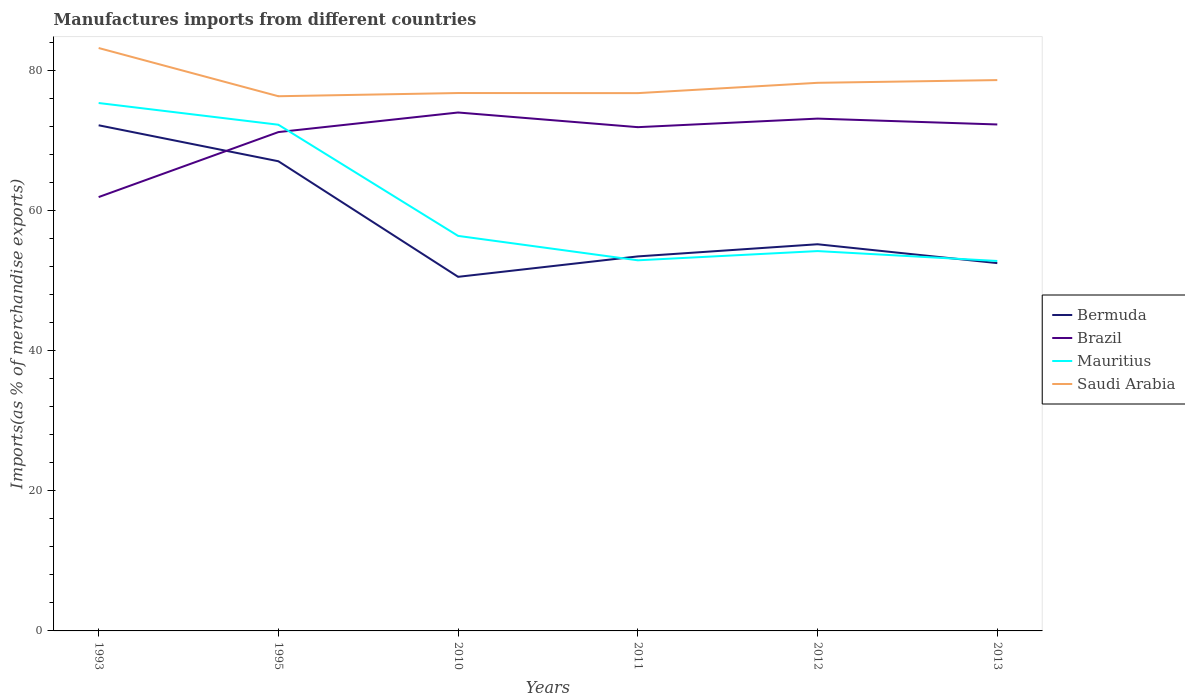How many different coloured lines are there?
Give a very brief answer. 4. Across all years, what is the maximum percentage of imports to different countries in Bermuda?
Make the answer very short. 50.55. In which year was the percentage of imports to different countries in Brazil maximum?
Your answer should be compact. 1993. What is the total percentage of imports to different countries in Brazil in the graph?
Keep it short and to the point. 2.09. What is the difference between the highest and the second highest percentage of imports to different countries in Brazil?
Your response must be concise. 12.07. How many lines are there?
Your answer should be compact. 4. How many years are there in the graph?
Provide a short and direct response. 6. What is the difference between two consecutive major ticks on the Y-axis?
Your response must be concise. 20. Are the values on the major ticks of Y-axis written in scientific E-notation?
Ensure brevity in your answer.  No. Does the graph contain grids?
Provide a short and direct response. No. Where does the legend appear in the graph?
Provide a succinct answer. Center right. What is the title of the graph?
Provide a short and direct response. Manufactures imports from different countries. What is the label or title of the Y-axis?
Give a very brief answer. Imports(as % of merchandise exports). What is the Imports(as % of merchandise exports) of Bermuda in 1993?
Your answer should be compact. 72.18. What is the Imports(as % of merchandise exports) in Brazil in 1993?
Offer a very short reply. 61.93. What is the Imports(as % of merchandise exports) in Mauritius in 1993?
Provide a succinct answer. 75.36. What is the Imports(as % of merchandise exports) in Saudi Arabia in 1993?
Provide a short and direct response. 83.21. What is the Imports(as % of merchandise exports) in Bermuda in 1995?
Give a very brief answer. 67.04. What is the Imports(as % of merchandise exports) in Brazil in 1995?
Offer a very short reply. 71.21. What is the Imports(as % of merchandise exports) of Mauritius in 1995?
Provide a short and direct response. 72.26. What is the Imports(as % of merchandise exports) of Saudi Arabia in 1995?
Ensure brevity in your answer.  76.33. What is the Imports(as % of merchandise exports) in Bermuda in 2010?
Keep it short and to the point. 50.55. What is the Imports(as % of merchandise exports) of Brazil in 2010?
Keep it short and to the point. 74. What is the Imports(as % of merchandise exports) in Mauritius in 2010?
Give a very brief answer. 56.39. What is the Imports(as % of merchandise exports) in Saudi Arabia in 2010?
Your answer should be very brief. 76.78. What is the Imports(as % of merchandise exports) of Bermuda in 2011?
Your answer should be compact. 53.46. What is the Imports(as % of merchandise exports) of Brazil in 2011?
Provide a short and direct response. 71.91. What is the Imports(as % of merchandise exports) of Mauritius in 2011?
Your response must be concise. 52.91. What is the Imports(as % of merchandise exports) in Saudi Arabia in 2011?
Your answer should be very brief. 76.77. What is the Imports(as % of merchandise exports) in Bermuda in 2012?
Offer a terse response. 55.2. What is the Imports(as % of merchandise exports) of Brazil in 2012?
Keep it short and to the point. 73.13. What is the Imports(as % of merchandise exports) of Mauritius in 2012?
Your answer should be very brief. 54.22. What is the Imports(as % of merchandise exports) of Saudi Arabia in 2012?
Offer a terse response. 78.24. What is the Imports(as % of merchandise exports) in Bermuda in 2013?
Offer a very short reply. 52.5. What is the Imports(as % of merchandise exports) in Brazil in 2013?
Offer a very short reply. 72.29. What is the Imports(as % of merchandise exports) of Mauritius in 2013?
Give a very brief answer. 52.81. What is the Imports(as % of merchandise exports) in Saudi Arabia in 2013?
Provide a short and direct response. 78.63. Across all years, what is the maximum Imports(as % of merchandise exports) in Bermuda?
Give a very brief answer. 72.18. Across all years, what is the maximum Imports(as % of merchandise exports) in Brazil?
Make the answer very short. 74. Across all years, what is the maximum Imports(as % of merchandise exports) in Mauritius?
Give a very brief answer. 75.36. Across all years, what is the maximum Imports(as % of merchandise exports) in Saudi Arabia?
Provide a succinct answer. 83.21. Across all years, what is the minimum Imports(as % of merchandise exports) in Bermuda?
Provide a short and direct response. 50.55. Across all years, what is the minimum Imports(as % of merchandise exports) of Brazil?
Your response must be concise. 61.93. Across all years, what is the minimum Imports(as % of merchandise exports) in Mauritius?
Make the answer very short. 52.81. Across all years, what is the minimum Imports(as % of merchandise exports) of Saudi Arabia?
Keep it short and to the point. 76.33. What is the total Imports(as % of merchandise exports) of Bermuda in the graph?
Your answer should be very brief. 350.93. What is the total Imports(as % of merchandise exports) of Brazil in the graph?
Keep it short and to the point. 424.48. What is the total Imports(as % of merchandise exports) of Mauritius in the graph?
Give a very brief answer. 363.94. What is the total Imports(as % of merchandise exports) in Saudi Arabia in the graph?
Your answer should be compact. 469.96. What is the difference between the Imports(as % of merchandise exports) of Bermuda in 1993 and that in 1995?
Offer a very short reply. 5.13. What is the difference between the Imports(as % of merchandise exports) in Brazil in 1993 and that in 1995?
Your answer should be compact. -9.28. What is the difference between the Imports(as % of merchandise exports) of Mauritius in 1993 and that in 1995?
Your response must be concise. 3.1. What is the difference between the Imports(as % of merchandise exports) of Saudi Arabia in 1993 and that in 1995?
Offer a very short reply. 6.88. What is the difference between the Imports(as % of merchandise exports) of Bermuda in 1993 and that in 2010?
Offer a terse response. 21.63. What is the difference between the Imports(as % of merchandise exports) in Brazil in 1993 and that in 2010?
Give a very brief answer. -12.07. What is the difference between the Imports(as % of merchandise exports) in Mauritius in 1993 and that in 2010?
Offer a very short reply. 18.97. What is the difference between the Imports(as % of merchandise exports) in Saudi Arabia in 1993 and that in 2010?
Provide a short and direct response. 6.43. What is the difference between the Imports(as % of merchandise exports) in Bermuda in 1993 and that in 2011?
Make the answer very short. 18.72. What is the difference between the Imports(as % of merchandise exports) of Brazil in 1993 and that in 2011?
Provide a succinct answer. -9.98. What is the difference between the Imports(as % of merchandise exports) in Mauritius in 1993 and that in 2011?
Your response must be concise. 22.45. What is the difference between the Imports(as % of merchandise exports) of Saudi Arabia in 1993 and that in 2011?
Make the answer very short. 6.44. What is the difference between the Imports(as % of merchandise exports) of Bermuda in 1993 and that in 2012?
Give a very brief answer. 16.98. What is the difference between the Imports(as % of merchandise exports) of Brazil in 1993 and that in 2012?
Provide a succinct answer. -11.2. What is the difference between the Imports(as % of merchandise exports) of Mauritius in 1993 and that in 2012?
Provide a short and direct response. 21.14. What is the difference between the Imports(as % of merchandise exports) in Saudi Arabia in 1993 and that in 2012?
Provide a succinct answer. 4.97. What is the difference between the Imports(as % of merchandise exports) in Bermuda in 1993 and that in 2013?
Offer a terse response. 19.68. What is the difference between the Imports(as % of merchandise exports) in Brazil in 1993 and that in 2013?
Keep it short and to the point. -10.36. What is the difference between the Imports(as % of merchandise exports) in Mauritius in 1993 and that in 2013?
Provide a short and direct response. 22.55. What is the difference between the Imports(as % of merchandise exports) of Saudi Arabia in 1993 and that in 2013?
Your answer should be compact. 4.58. What is the difference between the Imports(as % of merchandise exports) in Bermuda in 1995 and that in 2010?
Provide a succinct answer. 16.5. What is the difference between the Imports(as % of merchandise exports) in Brazil in 1995 and that in 2010?
Provide a short and direct response. -2.8. What is the difference between the Imports(as % of merchandise exports) in Mauritius in 1995 and that in 2010?
Your answer should be very brief. 15.87. What is the difference between the Imports(as % of merchandise exports) of Saudi Arabia in 1995 and that in 2010?
Make the answer very short. -0.46. What is the difference between the Imports(as % of merchandise exports) of Bermuda in 1995 and that in 2011?
Your answer should be compact. 13.58. What is the difference between the Imports(as % of merchandise exports) in Brazil in 1995 and that in 2011?
Your answer should be very brief. -0.7. What is the difference between the Imports(as % of merchandise exports) of Mauritius in 1995 and that in 2011?
Your answer should be compact. 19.35. What is the difference between the Imports(as % of merchandise exports) of Saudi Arabia in 1995 and that in 2011?
Your response must be concise. -0.44. What is the difference between the Imports(as % of merchandise exports) of Bermuda in 1995 and that in 2012?
Ensure brevity in your answer.  11.85. What is the difference between the Imports(as % of merchandise exports) in Brazil in 1995 and that in 2012?
Offer a terse response. -1.92. What is the difference between the Imports(as % of merchandise exports) in Mauritius in 1995 and that in 2012?
Your answer should be very brief. 18.04. What is the difference between the Imports(as % of merchandise exports) in Saudi Arabia in 1995 and that in 2012?
Your answer should be very brief. -1.92. What is the difference between the Imports(as % of merchandise exports) of Bermuda in 1995 and that in 2013?
Provide a short and direct response. 14.54. What is the difference between the Imports(as % of merchandise exports) in Brazil in 1995 and that in 2013?
Your response must be concise. -1.09. What is the difference between the Imports(as % of merchandise exports) of Mauritius in 1995 and that in 2013?
Keep it short and to the point. 19.45. What is the difference between the Imports(as % of merchandise exports) of Saudi Arabia in 1995 and that in 2013?
Your answer should be very brief. -2.31. What is the difference between the Imports(as % of merchandise exports) of Bermuda in 2010 and that in 2011?
Keep it short and to the point. -2.91. What is the difference between the Imports(as % of merchandise exports) in Brazil in 2010 and that in 2011?
Provide a succinct answer. 2.09. What is the difference between the Imports(as % of merchandise exports) in Mauritius in 2010 and that in 2011?
Provide a succinct answer. 3.48. What is the difference between the Imports(as % of merchandise exports) in Saudi Arabia in 2010 and that in 2011?
Your answer should be compact. 0.01. What is the difference between the Imports(as % of merchandise exports) in Bermuda in 2010 and that in 2012?
Offer a terse response. -4.65. What is the difference between the Imports(as % of merchandise exports) in Brazil in 2010 and that in 2012?
Offer a very short reply. 0.87. What is the difference between the Imports(as % of merchandise exports) of Mauritius in 2010 and that in 2012?
Your answer should be compact. 2.17. What is the difference between the Imports(as % of merchandise exports) of Saudi Arabia in 2010 and that in 2012?
Your answer should be compact. -1.46. What is the difference between the Imports(as % of merchandise exports) of Bermuda in 2010 and that in 2013?
Offer a very short reply. -1.96. What is the difference between the Imports(as % of merchandise exports) of Brazil in 2010 and that in 2013?
Your response must be concise. 1.71. What is the difference between the Imports(as % of merchandise exports) in Mauritius in 2010 and that in 2013?
Ensure brevity in your answer.  3.58. What is the difference between the Imports(as % of merchandise exports) of Saudi Arabia in 2010 and that in 2013?
Ensure brevity in your answer.  -1.85. What is the difference between the Imports(as % of merchandise exports) in Bermuda in 2011 and that in 2012?
Provide a succinct answer. -1.74. What is the difference between the Imports(as % of merchandise exports) in Brazil in 2011 and that in 2012?
Provide a succinct answer. -1.22. What is the difference between the Imports(as % of merchandise exports) of Mauritius in 2011 and that in 2012?
Your response must be concise. -1.32. What is the difference between the Imports(as % of merchandise exports) of Saudi Arabia in 2011 and that in 2012?
Ensure brevity in your answer.  -1.47. What is the difference between the Imports(as % of merchandise exports) of Brazil in 2011 and that in 2013?
Provide a short and direct response. -0.38. What is the difference between the Imports(as % of merchandise exports) in Mauritius in 2011 and that in 2013?
Your answer should be very brief. 0.1. What is the difference between the Imports(as % of merchandise exports) in Saudi Arabia in 2011 and that in 2013?
Give a very brief answer. -1.86. What is the difference between the Imports(as % of merchandise exports) in Bermuda in 2012 and that in 2013?
Offer a very short reply. 2.69. What is the difference between the Imports(as % of merchandise exports) in Brazil in 2012 and that in 2013?
Your response must be concise. 0.84. What is the difference between the Imports(as % of merchandise exports) of Mauritius in 2012 and that in 2013?
Provide a short and direct response. 1.41. What is the difference between the Imports(as % of merchandise exports) of Saudi Arabia in 2012 and that in 2013?
Give a very brief answer. -0.39. What is the difference between the Imports(as % of merchandise exports) in Bermuda in 1993 and the Imports(as % of merchandise exports) in Brazil in 1995?
Ensure brevity in your answer.  0.97. What is the difference between the Imports(as % of merchandise exports) in Bermuda in 1993 and the Imports(as % of merchandise exports) in Mauritius in 1995?
Your response must be concise. -0.08. What is the difference between the Imports(as % of merchandise exports) of Bermuda in 1993 and the Imports(as % of merchandise exports) of Saudi Arabia in 1995?
Provide a short and direct response. -4.15. What is the difference between the Imports(as % of merchandise exports) of Brazil in 1993 and the Imports(as % of merchandise exports) of Mauritius in 1995?
Your response must be concise. -10.33. What is the difference between the Imports(as % of merchandise exports) in Brazil in 1993 and the Imports(as % of merchandise exports) in Saudi Arabia in 1995?
Make the answer very short. -14.39. What is the difference between the Imports(as % of merchandise exports) in Mauritius in 1993 and the Imports(as % of merchandise exports) in Saudi Arabia in 1995?
Offer a very short reply. -0.97. What is the difference between the Imports(as % of merchandise exports) of Bermuda in 1993 and the Imports(as % of merchandise exports) of Brazil in 2010?
Your response must be concise. -1.82. What is the difference between the Imports(as % of merchandise exports) in Bermuda in 1993 and the Imports(as % of merchandise exports) in Mauritius in 2010?
Give a very brief answer. 15.79. What is the difference between the Imports(as % of merchandise exports) in Bermuda in 1993 and the Imports(as % of merchandise exports) in Saudi Arabia in 2010?
Your answer should be compact. -4.6. What is the difference between the Imports(as % of merchandise exports) of Brazil in 1993 and the Imports(as % of merchandise exports) of Mauritius in 2010?
Provide a short and direct response. 5.54. What is the difference between the Imports(as % of merchandise exports) of Brazil in 1993 and the Imports(as % of merchandise exports) of Saudi Arabia in 2010?
Your response must be concise. -14.85. What is the difference between the Imports(as % of merchandise exports) of Mauritius in 1993 and the Imports(as % of merchandise exports) of Saudi Arabia in 2010?
Offer a terse response. -1.42. What is the difference between the Imports(as % of merchandise exports) of Bermuda in 1993 and the Imports(as % of merchandise exports) of Brazil in 2011?
Your answer should be compact. 0.27. What is the difference between the Imports(as % of merchandise exports) in Bermuda in 1993 and the Imports(as % of merchandise exports) in Mauritius in 2011?
Make the answer very short. 19.27. What is the difference between the Imports(as % of merchandise exports) in Bermuda in 1993 and the Imports(as % of merchandise exports) in Saudi Arabia in 2011?
Provide a short and direct response. -4.59. What is the difference between the Imports(as % of merchandise exports) in Brazil in 1993 and the Imports(as % of merchandise exports) in Mauritius in 2011?
Your response must be concise. 9.03. What is the difference between the Imports(as % of merchandise exports) of Brazil in 1993 and the Imports(as % of merchandise exports) of Saudi Arabia in 2011?
Provide a succinct answer. -14.84. What is the difference between the Imports(as % of merchandise exports) of Mauritius in 1993 and the Imports(as % of merchandise exports) of Saudi Arabia in 2011?
Provide a succinct answer. -1.41. What is the difference between the Imports(as % of merchandise exports) of Bermuda in 1993 and the Imports(as % of merchandise exports) of Brazil in 2012?
Offer a very short reply. -0.95. What is the difference between the Imports(as % of merchandise exports) in Bermuda in 1993 and the Imports(as % of merchandise exports) in Mauritius in 2012?
Your response must be concise. 17.96. What is the difference between the Imports(as % of merchandise exports) in Bermuda in 1993 and the Imports(as % of merchandise exports) in Saudi Arabia in 2012?
Provide a succinct answer. -6.06. What is the difference between the Imports(as % of merchandise exports) in Brazil in 1993 and the Imports(as % of merchandise exports) in Mauritius in 2012?
Give a very brief answer. 7.71. What is the difference between the Imports(as % of merchandise exports) of Brazil in 1993 and the Imports(as % of merchandise exports) of Saudi Arabia in 2012?
Give a very brief answer. -16.31. What is the difference between the Imports(as % of merchandise exports) in Mauritius in 1993 and the Imports(as % of merchandise exports) in Saudi Arabia in 2012?
Give a very brief answer. -2.88. What is the difference between the Imports(as % of merchandise exports) in Bermuda in 1993 and the Imports(as % of merchandise exports) in Brazil in 2013?
Provide a succinct answer. -0.12. What is the difference between the Imports(as % of merchandise exports) of Bermuda in 1993 and the Imports(as % of merchandise exports) of Mauritius in 2013?
Make the answer very short. 19.37. What is the difference between the Imports(as % of merchandise exports) of Bermuda in 1993 and the Imports(as % of merchandise exports) of Saudi Arabia in 2013?
Provide a short and direct response. -6.45. What is the difference between the Imports(as % of merchandise exports) in Brazil in 1993 and the Imports(as % of merchandise exports) in Mauritius in 2013?
Your answer should be very brief. 9.12. What is the difference between the Imports(as % of merchandise exports) in Brazil in 1993 and the Imports(as % of merchandise exports) in Saudi Arabia in 2013?
Provide a succinct answer. -16.7. What is the difference between the Imports(as % of merchandise exports) of Mauritius in 1993 and the Imports(as % of merchandise exports) of Saudi Arabia in 2013?
Your answer should be compact. -3.27. What is the difference between the Imports(as % of merchandise exports) in Bermuda in 1995 and the Imports(as % of merchandise exports) in Brazil in 2010?
Offer a very short reply. -6.96. What is the difference between the Imports(as % of merchandise exports) of Bermuda in 1995 and the Imports(as % of merchandise exports) of Mauritius in 2010?
Your response must be concise. 10.65. What is the difference between the Imports(as % of merchandise exports) of Bermuda in 1995 and the Imports(as % of merchandise exports) of Saudi Arabia in 2010?
Your answer should be very brief. -9.74. What is the difference between the Imports(as % of merchandise exports) in Brazil in 1995 and the Imports(as % of merchandise exports) in Mauritius in 2010?
Your answer should be compact. 14.82. What is the difference between the Imports(as % of merchandise exports) of Brazil in 1995 and the Imports(as % of merchandise exports) of Saudi Arabia in 2010?
Your answer should be very brief. -5.58. What is the difference between the Imports(as % of merchandise exports) of Mauritius in 1995 and the Imports(as % of merchandise exports) of Saudi Arabia in 2010?
Offer a very short reply. -4.52. What is the difference between the Imports(as % of merchandise exports) of Bermuda in 1995 and the Imports(as % of merchandise exports) of Brazil in 2011?
Make the answer very short. -4.87. What is the difference between the Imports(as % of merchandise exports) of Bermuda in 1995 and the Imports(as % of merchandise exports) of Mauritius in 2011?
Make the answer very short. 14.14. What is the difference between the Imports(as % of merchandise exports) of Bermuda in 1995 and the Imports(as % of merchandise exports) of Saudi Arabia in 2011?
Provide a succinct answer. -9.72. What is the difference between the Imports(as % of merchandise exports) of Brazil in 1995 and the Imports(as % of merchandise exports) of Mauritius in 2011?
Keep it short and to the point. 18.3. What is the difference between the Imports(as % of merchandise exports) of Brazil in 1995 and the Imports(as % of merchandise exports) of Saudi Arabia in 2011?
Ensure brevity in your answer.  -5.56. What is the difference between the Imports(as % of merchandise exports) in Mauritius in 1995 and the Imports(as % of merchandise exports) in Saudi Arabia in 2011?
Keep it short and to the point. -4.51. What is the difference between the Imports(as % of merchandise exports) in Bermuda in 1995 and the Imports(as % of merchandise exports) in Brazil in 2012?
Your response must be concise. -6.09. What is the difference between the Imports(as % of merchandise exports) in Bermuda in 1995 and the Imports(as % of merchandise exports) in Mauritius in 2012?
Your response must be concise. 12.82. What is the difference between the Imports(as % of merchandise exports) of Bermuda in 1995 and the Imports(as % of merchandise exports) of Saudi Arabia in 2012?
Keep it short and to the point. -11.2. What is the difference between the Imports(as % of merchandise exports) in Brazil in 1995 and the Imports(as % of merchandise exports) in Mauritius in 2012?
Offer a terse response. 16.99. What is the difference between the Imports(as % of merchandise exports) in Brazil in 1995 and the Imports(as % of merchandise exports) in Saudi Arabia in 2012?
Your response must be concise. -7.04. What is the difference between the Imports(as % of merchandise exports) of Mauritius in 1995 and the Imports(as % of merchandise exports) of Saudi Arabia in 2012?
Your response must be concise. -5.98. What is the difference between the Imports(as % of merchandise exports) of Bermuda in 1995 and the Imports(as % of merchandise exports) of Brazil in 2013?
Offer a very short reply. -5.25. What is the difference between the Imports(as % of merchandise exports) of Bermuda in 1995 and the Imports(as % of merchandise exports) of Mauritius in 2013?
Offer a terse response. 14.24. What is the difference between the Imports(as % of merchandise exports) of Bermuda in 1995 and the Imports(as % of merchandise exports) of Saudi Arabia in 2013?
Keep it short and to the point. -11.59. What is the difference between the Imports(as % of merchandise exports) in Brazil in 1995 and the Imports(as % of merchandise exports) in Mauritius in 2013?
Your response must be concise. 18.4. What is the difference between the Imports(as % of merchandise exports) in Brazil in 1995 and the Imports(as % of merchandise exports) in Saudi Arabia in 2013?
Your answer should be very brief. -7.42. What is the difference between the Imports(as % of merchandise exports) in Mauritius in 1995 and the Imports(as % of merchandise exports) in Saudi Arabia in 2013?
Provide a short and direct response. -6.37. What is the difference between the Imports(as % of merchandise exports) of Bermuda in 2010 and the Imports(as % of merchandise exports) of Brazil in 2011?
Offer a terse response. -21.36. What is the difference between the Imports(as % of merchandise exports) in Bermuda in 2010 and the Imports(as % of merchandise exports) in Mauritius in 2011?
Your answer should be compact. -2.36. What is the difference between the Imports(as % of merchandise exports) in Bermuda in 2010 and the Imports(as % of merchandise exports) in Saudi Arabia in 2011?
Keep it short and to the point. -26.22. What is the difference between the Imports(as % of merchandise exports) of Brazil in 2010 and the Imports(as % of merchandise exports) of Mauritius in 2011?
Give a very brief answer. 21.1. What is the difference between the Imports(as % of merchandise exports) in Brazil in 2010 and the Imports(as % of merchandise exports) in Saudi Arabia in 2011?
Offer a very short reply. -2.77. What is the difference between the Imports(as % of merchandise exports) in Mauritius in 2010 and the Imports(as % of merchandise exports) in Saudi Arabia in 2011?
Give a very brief answer. -20.38. What is the difference between the Imports(as % of merchandise exports) of Bermuda in 2010 and the Imports(as % of merchandise exports) of Brazil in 2012?
Give a very brief answer. -22.58. What is the difference between the Imports(as % of merchandise exports) of Bermuda in 2010 and the Imports(as % of merchandise exports) of Mauritius in 2012?
Provide a succinct answer. -3.67. What is the difference between the Imports(as % of merchandise exports) of Bermuda in 2010 and the Imports(as % of merchandise exports) of Saudi Arabia in 2012?
Offer a very short reply. -27.69. What is the difference between the Imports(as % of merchandise exports) of Brazil in 2010 and the Imports(as % of merchandise exports) of Mauritius in 2012?
Provide a succinct answer. 19.78. What is the difference between the Imports(as % of merchandise exports) of Brazil in 2010 and the Imports(as % of merchandise exports) of Saudi Arabia in 2012?
Your response must be concise. -4.24. What is the difference between the Imports(as % of merchandise exports) of Mauritius in 2010 and the Imports(as % of merchandise exports) of Saudi Arabia in 2012?
Make the answer very short. -21.85. What is the difference between the Imports(as % of merchandise exports) of Bermuda in 2010 and the Imports(as % of merchandise exports) of Brazil in 2013?
Provide a short and direct response. -21.75. What is the difference between the Imports(as % of merchandise exports) of Bermuda in 2010 and the Imports(as % of merchandise exports) of Mauritius in 2013?
Give a very brief answer. -2.26. What is the difference between the Imports(as % of merchandise exports) of Bermuda in 2010 and the Imports(as % of merchandise exports) of Saudi Arabia in 2013?
Ensure brevity in your answer.  -28.08. What is the difference between the Imports(as % of merchandise exports) of Brazil in 2010 and the Imports(as % of merchandise exports) of Mauritius in 2013?
Offer a terse response. 21.2. What is the difference between the Imports(as % of merchandise exports) of Brazil in 2010 and the Imports(as % of merchandise exports) of Saudi Arabia in 2013?
Give a very brief answer. -4.63. What is the difference between the Imports(as % of merchandise exports) in Mauritius in 2010 and the Imports(as % of merchandise exports) in Saudi Arabia in 2013?
Your response must be concise. -22.24. What is the difference between the Imports(as % of merchandise exports) in Bermuda in 2011 and the Imports(as % of merchandise exports) in Brazil in 2012?
Provide a short and direct response. -19.67. What is the difference between the Imports(as % of merchandise exports) in Bermuda in 2011 and the Imports(as % of merchandise exports) in Mauritius in 2012?
Your response must be concise. -0.76. What is the difference between the Imports(as % of merchandise exports) in Bermuda in 2011 and the Imports(as % of merchandise exports) in Saudi Arabia in 2012?
Offer a very short reply. -24.78. What is the difference between the Imports(as % of merchandise exports) of Brazil in 2011 and the Imports(as % of merchandise exports) of Mauritius in 2012?
Offer a terse response. 17.69. What is the difference between the Imports(as % of merchandise exports) in Brazil in 2011 and the Imports(as % of merchandise exports) in Saudi Arabia in 2012?
Your response must be concise. -6.33. What is the difference between the Imports(as % of merchandise exports) in Mauritius in 2011 and the Imports(as % of merchandise exports) in Saudi Arabia in 2012?
Your answer should be very brief. -25.34. What is the difference between the Imports(as % of merchandise exports) of Bermuda in 2011 and the Imports(as % of merchandise exports) of Brazil in 2013?
Your answer should be very brief. -18.83. What is the difference between the Imports(as % of merchandise exports) in Bermuda in 2011 and the Imports(as % of merchandise exports) in Mauritius in 2013?
Provide a succinct answer. 0.65. What is the difference between the Imports(as % of merchandise exports) of Bermuda in 2011 and the Imports(as % of merchandise exports) of Saudi Arabia in 2013?
Provide a short and direct response. -25.17. What is the difference between the Imports(as % of merchandise exports) of Brazil in 2011 and the Imports(as % of merchandise exports) of Mauritius in 2013?
Ensure brevity in your answer.  19.1. What is the difference between the Imports(as % of merchandise exports) in Brazil in 2011 and the Imports(as % of merchandise exports) in Saudi Arabia in 2013?
Make the answer very short. -6.72. What is the difference between the Imports(as % of merchandise exports) of Mauritius in 2011 and the Imports(as % of merchandise exports) of Saudi Arabia in 2013?
Offer a terse response. -25.73. What is the difference between the Imports(as % of merchandise exports) of Bermuda in 2012 and the Imports(as % of merchandise exports) of Brazil in 2013?
Make the answer very short. -17.1. What is the difference between the Imports(as % of merchandise exports) of Bermuda in 2012 and the Imports(as % of merchandise exports) of Mauritius in 2013?
Provide a short and direct response. 2.39. What is the difference between the Imports(as % of merchandise exports) in Bermuda in 2012 and the Imports(as % of merchandise exports) in Saudi Arabia in 2013?
Give a very brief answer. -23.43. What is the difference between the Imports(as % of merchandise exports) of Brazil in 2012 and the Imports(as % of merchandise exports) of Mauritius in 2013?
Your response must be concise. 20.32. What is the difference between the Imports(as % of merchandise exports) of Brazil in 2012 and the Imports(as % of merchandise exports) of Saudi Arabia in 2013?
Offer a terse response. -5.5. What is the difference between the Imports(as % of merchandise exports) in Mauritius in 2012 and the Imports(as % of merchandise exports) in Saudi Arabia in 2013?
Ensure brevity in your answer.  -24.41. What is the average Imports(as % of merchandise exports) in Bermuda per year?
Give a very brief answer. 58.49. What is the average Imports(as % of merchandise exports) in Brazil per year?
Make the answer very short. 70.75. What is the average Imports(as % of merchandise exports) of Mauritius per year?
Provide a succinct answer. 60.66. What is the average Imports(as % of merchandise exports) in Saudi Arabia per year?
Your answer should be very brief. 78.33. In the year 1993, what is the difference between the Imports(as % of merchandise exports) in Bermuda and Imports(as % of merchandise exports) in Brazil?
Provide a succinct answer. 10.25. In the year 1993, what is the difference between the Imports(as % of merchandise exports) in Bermuda and Imports(as % of merchandise exports) in Mauritius?
Keep it short and to the point. -3.18. In the year 1993, what is the difference between the Imports(as % of merchandise exports) of Bermuda and Imports(as % of merchandise exports) of Saudi Arabia?
Your answer should be compact. -11.03. In the year 1993, what is the difference between the Imports(as % of merchandise exports) of Brazil and Imports(as % of merchandise exports) of Mauritius?
Offer a terse response. -13.43. In the year 1993, what is the difference between the Imports(as % of merchandise exports) in Brazil and Imports(as % of merchandise exports) in Saudi Arabia?
Your response must be concise. -21.28. In the year 1993, what is the difference between the Imports(as % of merchandise exports) of Mauritius and Imports(as % of merchandise exports) of Saudi Arabia?
Your answer should be compact. -7.85. In the year 1995, what is the difference between the Imports(as % of merchandise exports) of Bermuda and Imports(as % of merchandise exports) of Brazil?
Give a very brief answer. -4.16. In the year 1995, what is the difference between the Imports(as % of merchandise exports) of Bermuda and Imports(as % of merchandise exports) of Mauritius?
Offer a terse response. -5.21. In the year 1995, what is the difference between the Imports(as % of merchandise exports) of Bermuda and Imports(as % of merchandise exports) of Saudi Arabia?
Offer a terse response. -9.28. In the year 1995, what is the difference between the Imports(as % of merchandise exports) of Brazil and Imports(as % of merchandise exports) of Mauritius?
Give a very brief answer. -1.05. In the year 1995, what is the difference between the Imports(as % of merchandise exports) in Brazil and Imports(as % of merchandise exports) in Saudi Arabia?
Your answer should be very brief. -5.12. In the year 1995, what is the difference between the Imports(as % of merchandise exports) in Mauritius and Imports(as % of merchandise exports) in Saudi Arabia?
Provide a succinct answer. -4.07. In the year 2010, what is the difference between the Imports(as % of merchandise exports) of Bermuda and Imports(as % of merchandise exports) of Brazil?
Make the answer very short. -23.46. In the year 2010, what is the difference between the Imports(as % of merchandise exports) of Bermuda and Imports(as % of merchandise exports) of Mauritius?
Your response must be concise. -5.84. In the year 2010, what is the difference between the Imports(as % of merchandise exports) in Bermuda and Imports(as % of merchandise exports) in Saudi Arabia?
Your response must be concise. -26.23. In the year 2010, what is the difference between the Imports(as % of merchandise exports) of Brazil and Imports(as % of merchandise exports) of Mauritius?
Your response must be concise. 17.61. In the year 2010, what is the difference between the Imports(as % of merchandise exports) of Brazil and Imports(as % of merchandise exports) of Saudi Arabia?
Your answer should be very brief. -2.78. In the year 2010, what is the difference between the Imports(as % of merchandise exports) of Mauritius and Imports(as % of merchandise exports) of Saudi Arabia?
Offer a terse response. -20.39. In the year 2011, what is the difference between the Imports(as % of merchandise exports) of Bermuda and Imports(as % of merchandise exports) of Brazil?
Ensure brevity in your answer.  -18.45. In the year 2011, what is the difference between the Imports(as % of merchandise exports) of Bermuda and Imports(as % of merchandise exports) of Mauritius?
Your response must be concise. 0.56. In the year 2011, what is the difference between the Imports(as % of merchandise exports) in Bermuda and Imports(as % of merchandise exports) in Saudi Arabia?
Your response must be concise. -23.31. In the year 2011, what is the difference between the Imports(as % of merchandise exports) of Brazil and Imports(as % of merchandise exports) of Mauritius?
Ensure brevity in your answer.  19.01. In the year 2011, what is the difference between the Imports(as % of merchandise exports) of Brazil and Imports(as % of merchandise exports) of Saudi Arabia?
Ensure brevity in your answer.  -4.86. In the year 2011, what is the difference between the Imports(as % of merchandise exports) in Mauritius and Imports(as % of merchandise exports) in Saudi Arabia?
Provide a short and direct response. -23.86. In the year 2012, what is the difference between the Imports(as % of merchandise exports) of Bermuda and Imports(as % of merchandise exports) of Brazil?
Provide a short and direct response. -17.94. In the year 2012, what is the difference between the Imports(as % of merchandise exports) of Bermuda and Imports(as % of merchandise exports) of Mauritius?
Offer a very short reply. 0.97. In the year 2012, what is the difference between the Imports(as % of merchandise exports) of Bermuda and Imports(as % of merchandise exports) of Saudi Arabia?
Keep it short and to the point. -23.05. In the year 2012, what is the difference between the Imports(as % of merchandise exports) in Brazil and Imports(as % of merchandise exports) in Mauritius?
Your answer should be very brief. 18.91. In the year 2012, what is the difference between the Imports(as % of merchandise exports) of Brazil and Imports(as % of merchandise exports) of Saudi Arabia?
Make the answer very short. -5.11. In the year 2012, what is the difference between the Imports(as % of merchandise exports) in Mauritius and Imports(as % of merchandise exports) in Saudi Arabia?
Make the answer very short. -24.02. In the year 2013, what is the difference between the Imports(as % of merchandise exports) in Bermuda and Imports(as % of merchandise exports) in Brazil?
Give a very brief answer. -19.79. In the year 2013, what is the difference between the Imports(as % of merchandise exports) of Bermuda and Imports(as % of merchandise exports) of Mauritius?
Your answer should be very brief. -0.3. In the year 2013, what is the difference between the Imports(as % of merchandise exports) in Bermuda and Imports(as % of merchandise exports) in Saudi Arabia?
Offer a very short reply. -26.13. In the year 2013, what is the difference between the Imports(as % of merchandise exports) in Brazil and Imports(as % of merchandise exports) in Mauritius?
Offer a terse response. 19.49. In the year 2013, what is the difference between the Imports(as % of merchandise exports) in Brazil and Imports(as % of merchandise exports) in Saudi Arabia?
Your response must be concise. -6.34. In the year 2013, what is the difference between the Imports(as % of merchandise exports) of Mauritius and Imports(as % of merchandise exports) of Saudi Arabia?
Give a very brief answer. -25.82. What is the ratio of the Imports(as % of merchandise exports) of Bermuda in 1993 to that in 1995?
Your answer should be very brief. 1.08. What is the ratio of the Imports(as % of merchandise exports) in Brazil in 1993 to that in 1995?
Your response must be concise. 0.87. What is the ratio of the Imports(as % of merchandise exports) in Mauritius in 1993 to that in 1995?
Offer a terse response. 1.04. What is the ratio of the Imports(as % of merchandise exports) in Saudi Arabia in 1993 to that in 1995?
Ensure brevity in your answer.  1.09. What is the ratio of the Imports(as % of merchandise exports) of Bermuda in 1993 to that in 2010?
Ensure brevity in your answer.  1.43. What is the ratio of the Imports(as % of merchandise exports) in Brazil in 1993 to that in 2010?
Ensure brevity in your answer.  0.84. What is the ratio of the Imports(as % of merchandise exports) of Mauritius in 1993 to that in 2010?
Provide a short and direct response. 1.34. What is the ratio of the Imports(as % of merchandise exports) in Saudi Arabia in 1993 to that in 2010?
Offer a very short reply. 1.08. What is the ratio of the Imports(as % of merchandise exports) in Bermuda in 1993 to that in 2011?
Keep it short and to the point. 1.35. What is the ratio of the Imports(as % of merchandise exports) of Brazil in 1993 to that in 2011?
Offer a very short reply. 0.86. What is the ratio of the Imports(as % of merchandise exports) of Mauritius in 1993 to that in 2011?
Ensure brevity in your answer.  1.42. What is the ratio of the Imports(as % of merchandise exports) of Saudi Arabia in 1993 to that in 2011?
Keep it short and to the point. 1.08. What is the ratio of the Imports(as % of merchandise exports) of Bermuda in 1993 to that in 2012?
Keep it short and to the point. 1.31. What is the ratio of the Imports(as % of merchandise exports) of Brazil in 1993 to that in 2012?
Offer a terse response. 0.85. What is the ratio of the Imports(as % of merchandise exports) of Mauritius in 1993 to that in 2012?
Your answer should be compact. 1.39. What is the ratio of the Imports(as % of merchandise exports) of Saudi Arabia in 1993 to that in 2012?
Your answer should be very brief. 1.06. What is the ratio of the Imports(as % of merchandise exports) in Bermuda in 1993 to that in 2013?
Offer a terse response. 1.37. What is the ratio of the Imports(as % of merchandise exports) of Brazil in 1993 to that in 2013?
Your answer should be very brief. 0.86. What is the ratio of the Imports(as % of merchandise exports) in Mauritius in 1993 to that in 2013?
Your response must be concise. 1.43. What is the ratio of the Imports(as % of merchandise exports) in Saudi Arabia in 1993 to that in 2013?
Your answer should be very brief. 1.06. What is the ratio of the Imports(as % of merchandise exports) in Bermuda in 1995 to that in 2010?
Your answer should be compact. 1.33. What is the ratio of the Imports(as % of merchandise exports) of Brazil in 1995 to that in 2010?
Your answer should be compact. 0.96. What is the ratio of the Imports(as % of merchandise exports) in Mauritius in 1995 to that in 2010?
Your answer should be compact. 1.28. What is the ratio of the Imports(as % of merchandise exports) in Saudi Arabia in 1995 to that in 2010?
Make the answer very short. 0.99. What is the ratio of the Imports(as % of merchandise exports) in Bermuda in 1995 to that in 2011?
Offer a terse response. 1.25. What is the ratio of the Imports(as % of merchandise exports) of Brazil in 1995 to that in 2011?
Offer a terse response. 0.99. What is the ratio of the Imports(as % of merchandise exports) of Mauritius in 1995 to that in 2011?
Make the answer very short. 1.37. What is the ratio of the Imports(as % of merchandise exports) in Saudi Arabia in 1995 to that in 2011?
Your answer should be compact. 0.99. What is the ratio of the Imports(as % of merchandise exports) of Bermuda in 1995 to that in 2012?
Offer a very short reply. 1.21. What is the ratio of the Imports(as % of merchandise exports) in Brazil in 1995 to that in 2012?
Your response must be concise. 0.97. What is the ratio of the Imports(as % of merchandise exports) of Mauritius in 1995 to that in 2012?
Your answer should be very brief. 1.33. What is the ratio of the Imports(as % of merchandise exports) of Saudi Arabia in 1995 to that in 2012?
Your answer should be compact. 0.98. What is the ratio of the Imports(as % of merchandise exports) of Bermuda in 1995 to that in 2013?
Your response must be concise. 1.28. What is the ratio of the Imports(as % of merchandise exports) in Mauritius in 1995 to that in 2013?
Make the answer very short. 1.37. What is the ratio of the Imports(as % of merchandise exports) in Saudi Arabia in 1995 to that in 2013?
Your answer should be compact. 0.97. What is the ratio of the Imports(as % of merchandise exports) in Bermuda in 2010 to that in 2011?
Offer a terse response. 0.95. What is the ratio of the Imports(as % of merchandise exports) in Brazil in 2010 to that in 2011?
Keep it short and to the point. 1.03. What is the ratio of the Imports(as % of merchandise exports) in Mauritius in 2010 to that in 2011?
Make the answer very short. 1.07. What is the ratio of the Imports(as % of merchandise exports) in Saudi Arabia in 2010 to that in 2011?
Make the answer very short. 1. What is the ratio of the Imports(as % of merchandise exports) of Bermuda in 2010 to that in 2012?
Your response must be concise. 0.92. What is the ratio of the Imports(as % of merchandise exports) in Brazil in 2010 to that in 2012?
Your answer should be compact. 1.01. What is the ratio of the Imports(as % of merchandise exports) of Saudi Arabia in 2010 to that in 2012?
Keep it short and to the point. 0.98. What is the ratio of the Imports(as % of merchandise exports) in Bermuda in 2010 to that in 2013?
Ensure brevity in your answer.  0.96. What is the ratio of the Imports(as % of merchandise exports) in Brazil in 2010 to that in 2013?
Provide a short and direct response. 1.02. What is the ratio of the Imports(as % of merchandise exports) in Mauritius in 2010 to that in 2013?
Provide a succinct answer. 1.07. What is the ratio of the Imports(as % of merchandise exports) in Saudi Arabia in 2010 to that in 2013?
Your answer should be compact. 0.98. What is the ratio of the Imports(as % of merchandise exports) in Bermuda in 2011 to that in 2012?
Ensure brevity in your answer.  0.97. What is the ratio of the Imports(as % of merchandise exports) of Brazil in 2011 to that in 2012?
Ensure brevity in your answer.  0.98. What is the ratio of the Imports(as % of merchandise exports) of Mauritius in 2011 to that in 2012?
Your answer should be very brief. 0.98. What is the ratio of the Imports(as % of merchandise exports) in Saudi Arabia in 2011 to that in 2012?
Provide a succinct answer. 0.98. What is the ratio of the Imports(as % of merchandise exports) of Bermuda in 2011 to that in 2013?
Ensure brevity in your answer.  1.02. What is the ratio of the Imports(as % of merchandise exports) in Brazil in 2011 to that in 2013?
Your answer should be compact. 0.99. What is the ratio of the Imports(as % of merchandise exports) in Saudi Arabia in 2011 to that in 2013?
Your answer should be compact. 0.98. What is the ratio of the Imports(as % of merchandise exports) in Bermuda in 2012 to that in 2013?
Ensure brevity in your answer.  1.05. What is the ratio of the Imports(as % of merchandise exports) of Brazil in 2012 to that in 2013?
Offer a terse response. 1.01. What is the ratio of the Imports(as % of merchandise exports) in Mauritius in 2012 to that in 2013?
Offer a terse response. 1.03. What is the difference between the highest and the second highest Imports(as % of merchandise exports) in Bermuda?
Make the answer very short. 5.13. What is the difference between the highest and the second highest Imports(as % of merchandise exports) of Brazil?
Offer a terse response. 0.87. What is the difference between the highest and the second highest Imports(as % of merchandise exports) of Mauritius?
Keep it short and to the point. 3.1. What is the difference between the highest and the second highest Imports(as % of merchandise exports) of Saudi Arabia?
Provide a short and direct response. 4.58. What is the difference between the highest and the lowest Imports(as % of merchandise exports) in Bermuda?
Offer a terse response. 21.63. What is the difference between the highest and the lowest Imports(as % of merchandise exports) in Brazil?
Your answer should be very brief. 12.07. What is the difference between the highest and the lowest Imports(as % of merchandise exports) in Mauritius?
Provide a short and direct response. 22.55. What is the difference between the highest and the lowest Imports(as % of merchandise exports) in Saudi Arabia?
Make the answer very short. 6.88. 